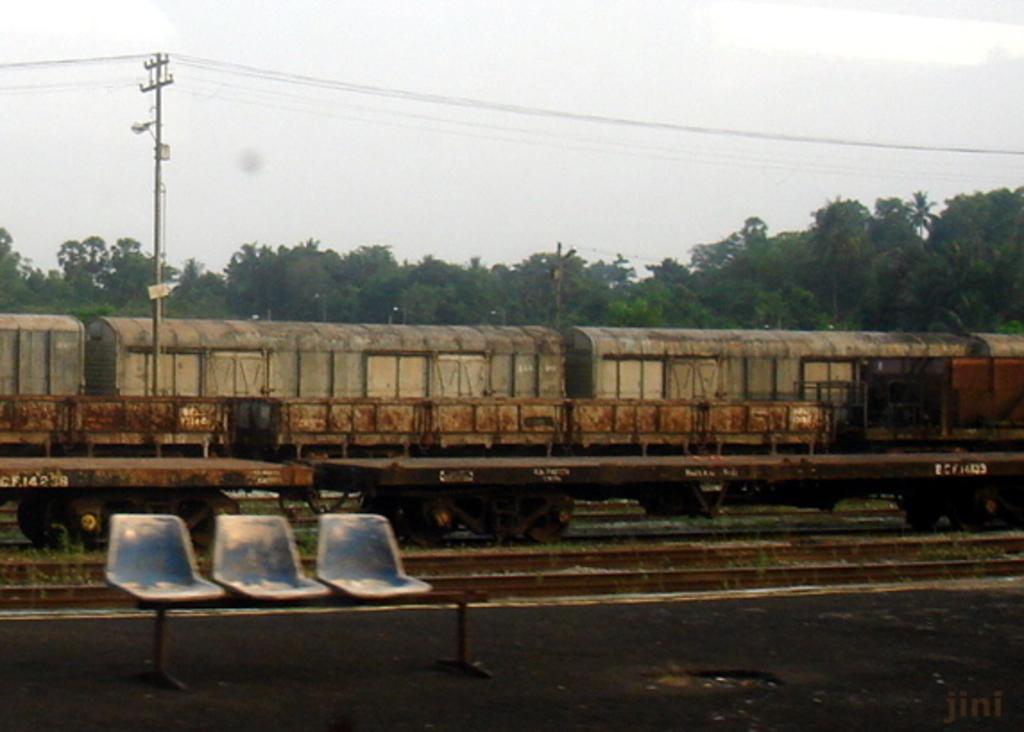How would you summarize this image in a sentence or two? Far there are number of trees. This is a goods train on a track. Front there are 3 chairs. Sky is in white color. This is a current pole with cables. 